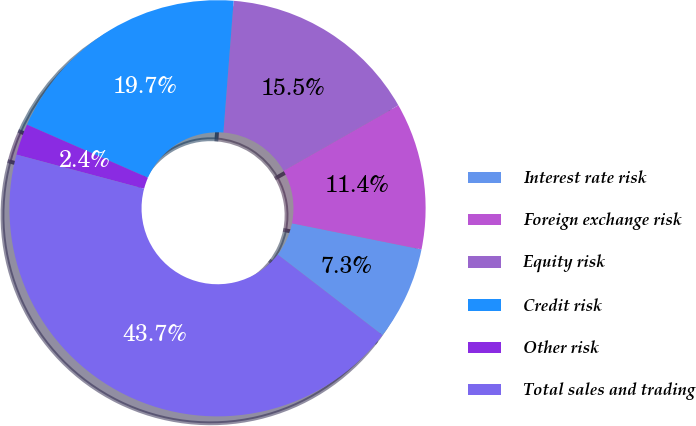Convert chart to OTSL. <chart><loc_0><loc_0><loc_500><loc_500><pie_chart><fcel>Interest rate risk<fcel>Foreign exchange risk<fcel>Equity risk<fcel>Credit risk<fcel>Other risk<fcel>Total sales and trading<nl><fcel>7.27%<fcel>11.4%<fcel>15.53%<fcel>19.65%<fcel>2.43%<fcel>43.71%<nl></chart> 